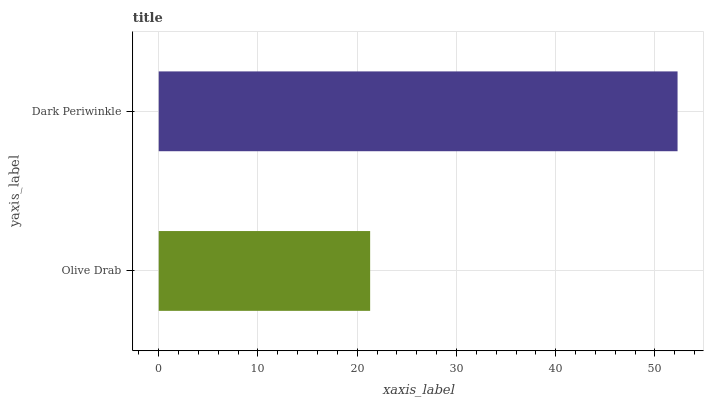Is Olive Drab the minimum?
Answer yes or no. Yes. Is Dark Periwinkle the maximum?
Answer yes or no. Yes. Is Dark Periwinkle the minimum?
Answer yes or no. No. Is Dark Periwinkle greater than Olive Drab?
Answer yes or no. Yes. Is Olive Drab less than Dark Periwinkle?
Answer yes or no. Yes. Is Olive Drab greater than Dark Periwinkle?
Answer yes or no. No. Is Dark Periwinkle less than Olive Drab?
Answer yes or no. No. Is Dark Periwinkle the high median?
Answer yes or no. Yes. Is Olive Drab the low median?
Answer yes or no. Yes. Is Olive Drab the high median?
Answer yes or no. No. Is Dark Periwinkle the low median?
Answer yes or no. No. 